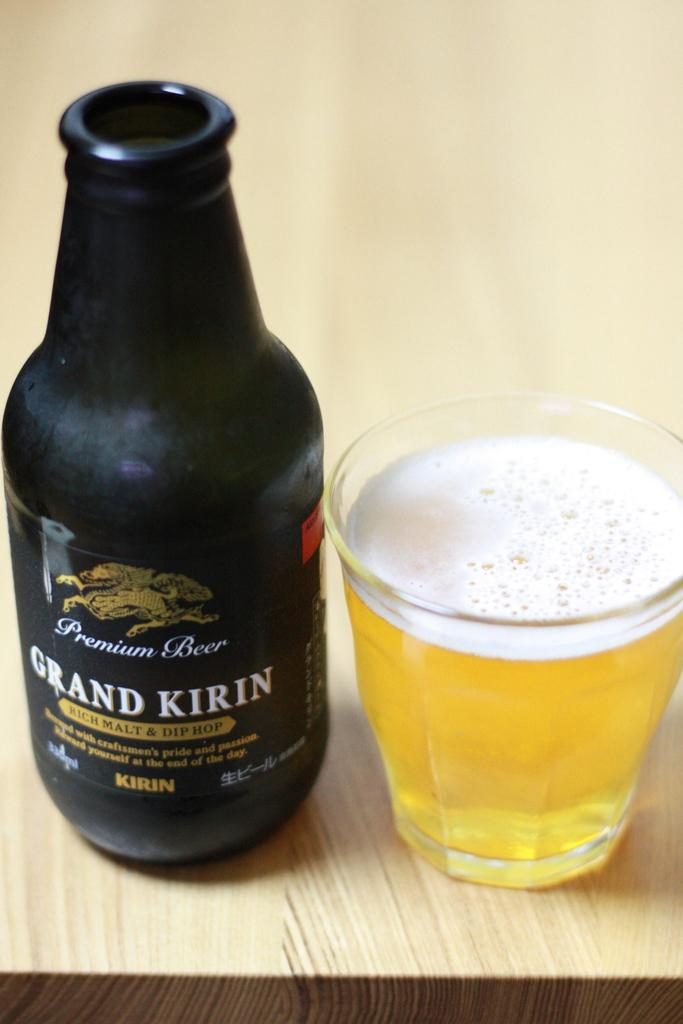Provide a one-sentence caption for the provided image. A black bottle of Grand Kirin Malt next to a full glass of beer. 